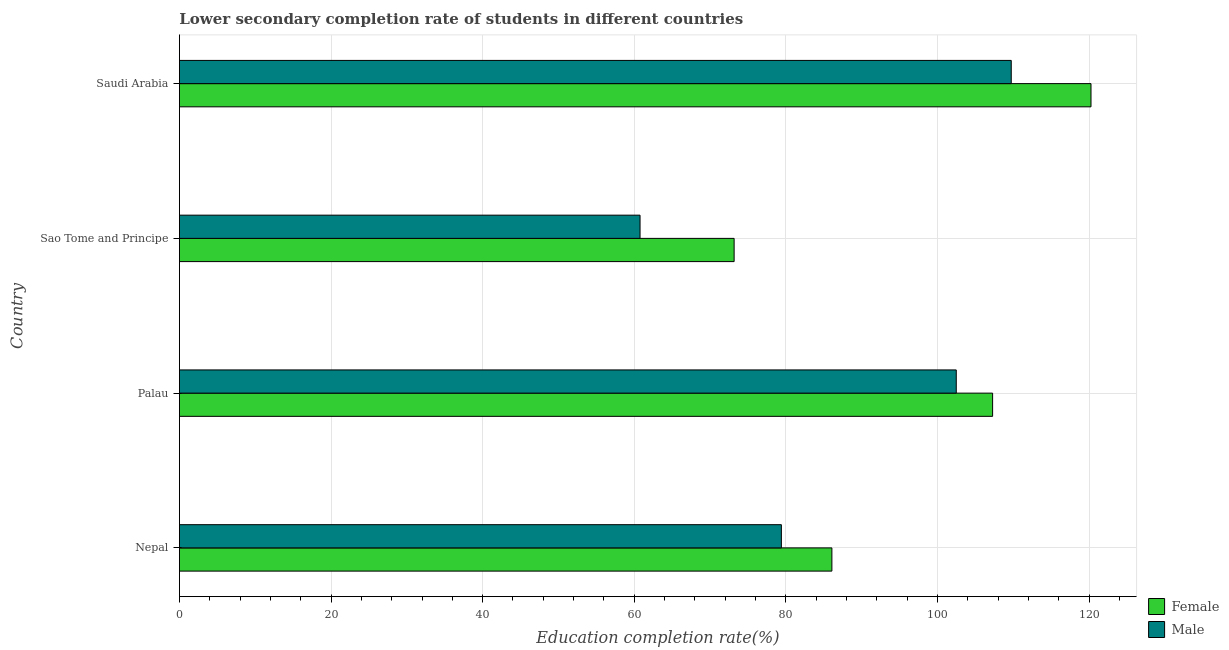How many groups of bars are there?
Ensure brevity in your answer.  4. Are the number of bars per tick equal to the number of legend labels?
Offer a very short reply. Yes. How many bars are there on the 3rd tick from the bottom?
Offer a terse response. 2. What is the label of the 3rd group of bars from the top?
Ensure brevity in your answer.  Palau. What is the education completion rate of male students in Saudi Arabia?
Provide a succinct answer. 109.73. Across all countries, what is the maximum education completion rate of female students?
Keep it short and to the point. 120.25. Across all countries, what is the minimum education completion rate of male students?
Offer a terse response. 60.76. In which country was the education completion rate of male students maximum?
Ensure brevity in your answer.  Saudi Arabia. In which country was the education completion rate of female students minimum?
Offer a terse response. Sao Tome and Principe. What is the total education completion rate of male students in the graph?
Ensure brevity in your answer.  352.38. What is the difference between the education completion rate of male students in Nepal and that in Palau?
Offer a very short reply. -23.07. What is the difference between the education completion rate of female students in Sao Tome and Principe and the education completion rate of male students in Palau?
Give a very brief answer. -29.3. What is the average education completion rate of female students per country?
Provide a short and direct response. 96.69. What is the difference between the education completion rate of female students and education completion rate of male students in Saudi Arabia?
Offer a terse response. 10.52. What is the ratio of the education completion rate of female students in Sao Tome and Principe to that in Saudi Arabia?
Your answer should be very brief. 0.61. Is the difference between the education completion rate of female students in Nepal and Palau greater than the difference between the education completion rate of male students in Nepal and Palau?
Give a very brief answer. Yes. What is the difference between the highest and the second highest education completion rate of male students?
Provide a short and direct response. 7.25. What is the difference between the highest and the lowest education completion rate of female students?
Offer a terse response. 47.08. What does the 2nd bar from the top in Sao Tome and Principe represents?
Give a very brief answer. Female. What does the 2nd bar from the bottom in Palau represents?
Offer a terse response. Male. How many bars are there?
Your answer should be compact. 8. Are all the bars in the graph horizontal?
Make the answer very short. Yes. How many countries are there in the graph?
Provide a short and direct response. 4. Where does the legend appear in the graph?
Ensure brevity in your answer.  Bottom right. How many legend labels are there?
Make the answer very short. 2. What is the title of the graph?
Ensure brevity in your answer.  Lower secondary completion rate of students in different countries. Does "By country of asylum" appear as one of the legend labels in the graph?
Your response must be concise. No. What is the label or title of the X-axis?
Your response must be concise. Education completion rate(%). What is the Education completion rate(%) in Female in Nepal?
Give a very brief answer. 86.07. What is the Education completion rate(%) of Male in Nepal?
Keep it short and to the point. 79.41. What is the Education completion rate(%) of Female in Palau?
Keep it short and to the point. 107.27. What is the Education completion rate(%) of Male in Palau?
Keep it short and to the point. 102.48. What is the Education completion rate(%) of Female in Sao Tome and Principe?
Give a very brief answer. 73.18. What is the Education completion rate(%) of Male in Sao Tome and Principe?
Keep it short and to the point. 60.76. What is the Education completion rate(%) in Female in Saudi Arabia?
Offer a terse response. 120.25. What is the Education completion rate(%) of Male in Saudi Arabia?
Your answer should be very brief. 109.73. Across all countries, what is the maximum Education completion rate(%) in Female?
Offer a very short reply. 120.25. Across all countries, what is the maximum Education completion rate(%) in Male?
Provide a short and direct response. 109.73. Across all countries, what is the minimum Education completion rate(%) in Female?
Your answer should be very brief. 73.18. Across all countries, what is the minimum Education completion rate(%) in Male?
Offer a very short reply. 60.76. What is the total Education completion rate(%) of Female in the graph?
Offer a terse response. 386.77. What is the total Education completion rate(%) in Male in the graph?
Ensure brevity in your answer.  352.38. What is the difference between the Education completion rate(%) in Female in Nepal and that in Palau?
Offer a terse response. -21.2. What is the difference between the Education completion rate(%) of Male in Nepal and that in Palau?
Keep it short and to the point. -23.07. What is the difference between the Education completion rate(%) of Female in Nepal and that in Sao Tome and Principe?
Provide a succinct answer. 12.89. What is the difference between the Education completion rate(%) in Male in Nepal and that in Sao Tome and Principe?
Make the answer very short. 18.64. What is the difference between the Education completion rate(%) in Female in Nepal and that in Saudi Arabia?
Provide a short and direct response. -34.18. What is the difference between the Education completion rate(%) in Male in Nepal and that in Saudi Arabia?
Keep it short and to the point. -30.32. What is the difference between the Education completion rate(%) of Female in Palau and that in Sao Tome and Principe?
Give a very brief answer. 34.1. What is the difference between the Education completion rate(%) of Male in Palau and that in Sao Tome and Principe?
Provide a succinct answer. 41.72. What is the difference between the Education completion rate(%) in Female in Palau and that in Saudi Arabia?
Your answer should be compact. -12.98. What is the difference between the Education completion rate(%) of Male in Palau and that in Saudi Arabia?
Ensure brevity in your answer.  -7.25. What is the difference between the Education completion rate(%) of Female in Sao Tome and Principe and that in Saudi Arabia?
Your response must be concise. -47.08. What is the difference between the Education completion rate(%) in Male in Sao Tome and Principe and that in Saudi Arabia?
Ensure brevity in your answer.  -48.97. What is the difference between the Education completion rate(%) in Female in Nepal and the Education completion rate(%) in Male in Palau?
Make the answer very short. -16.41. What is the difference between the Education completion rate(%) of Female in Nepal and the Education completion rate(%) of Male in Sao Tome and Principe?
Provide a succinct answer. 25.31. What is the difference between the Education completion rate(%) of Female in Nepal and the Education completion rate(%) of Male in Saudi Arabia?
Give a very brief answer. -23.66. What is the difference between the Education completion rate(%) of Female in Palau and the Education completion rate(%) of Male in Sao Tome and Principe?
Your answer should be compact. 46.51. What is the difference between the Education completion rate(%) of Female in Palau and the Education completion rate(%) of Male in Saudi Arabia?
Your response must be concise. -2.46. What is the difference between the Education completion rate(%) of Female in Sao Tome and Principe and the Education completion rate(%) of Male in Saudi Arabia?
Offer a very short reply. -36.56. What is the average Education completion rate(%) of Female per country?
Keep it short and to the point. 96.69. What is the average Education completion rate(%) in Male per country?
Your answer should be very brief. 88.1. What is the difference between the Education completion rate(%) in Female and Education completion rate(%) in Male in Nepal?
Provide a succinct answer. 6.66. What is the difference between the Education completion rate(%) in Female and Education completion rate(%) in Male in Palau?
Provide a short and direct response. 4.79. What is the difference between the Education completion rate(%) of Female and Education completion rate(%) of Male in Sao Tome and Principe?
Provide a succinct answer. 12.41. What is the difference between the Education completion rate(%) in Female and Education completion rate(%) in Male in Saudi Arabia?
Give a very brief answer. 10.52. What is the ratio of the Education completion rate(%) of Female in Nepal to that in Palau?
Ensure brevity in your answer.  0.8. What is the ratio of the Education completion rate(%) of Male in Nepal to that in Palau?
Ensure brevity in your answer.  0.77. What is the ratio of the Education completion rate(%) in Female in Nepal to that in Sao Tome and Principe?
Your answer should be compact. 1.18. What is the ratio of the Education completion rate(%) of Male in Nepal to that in Sao Tome and Principe?
Offer a very short reply. 1.31. What is the ratio of the Education completion rate(%) of Female in Nepal to that in Saudi Arabia?
Provide a short and direct response. 0.72. What is the ratio of the Education completion rate(%) in Male in Nepal to that in Saudi Arabia?
Ensure brevity in your answer.  0.72. What is the ratio of the Education completion rate(%) in Female in Palau to that in Sao Tome and Principe?
Offer a terse response. 1.47. What is the ratio of the Education completion rate(%) in Male in Palau to that in Sao Tome and Principe?
Your answer should be very brief. 1.69. What is the ratio of the Education completion rate(%) of Female in Palau to that in Saudi Arabia?
Provide a short and direct response. 0.89. What is the ratio of the Education completion rate(%) in Male in Palau to that in Saudi Arabia?
Your response must be concise. 0.93. What is the ratio of the Education completion rate(%) of Female in Sao Tome and Principe to that in Saudi Arabia?
Your answer should be very brief. 0.61. What is the ratio of the Education completion rate(%) in Male in Sao Tome and Principe to that in Saudi Arabia?
Your answer should be very brief. 0.55. What is the difference between the highest and the second highest Education completion rate(%) in Female?
Provide a succinct answer. 12.98. What is the difference between the highest and the second highest Education completion rate(%) in Male?
Offer a very short reply. 7.25. What is the difference between the highest and the lowest Education completion rate(%) in Female?
Provide a succinct answer. 47.08. What is the difference between the highest and the lowest Education completion rate(%) of Male?
Provide a short and direct response. 48.97. 